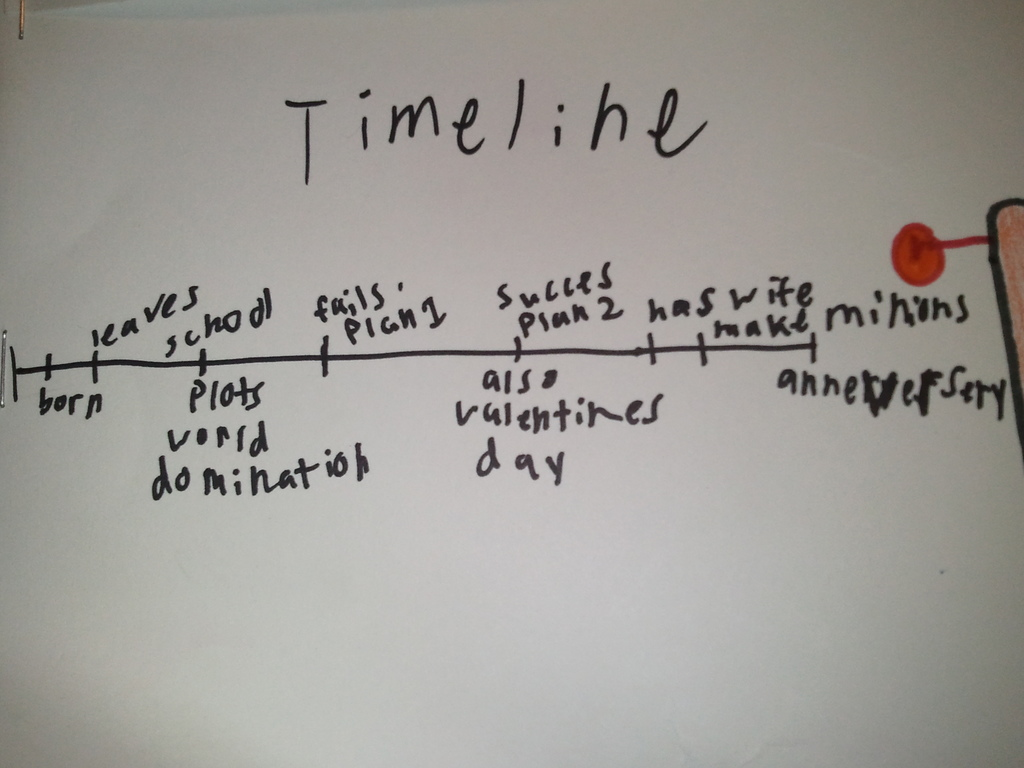What is this photo about'? The image presents a hand-drawn timeline, titled "Timeline", marked with a red pushpin on the right side. The timeline traces a series of events, beginning with "born" and concluding with "anniversary". The events are represented by small vertical lines along a black line, symbolizing the progression of time. 

The sequence of events unfolds as follows: After birth, the individual leaves school, then plots world domination. Despite an initial failure, they succeed on their second plan, savoring a taste of victory. Interestingly, this victorious moment coincides with Valentine's Day. The timeline ends with an unspecified anniversary, leaving room for interpretation and future events. 

This timeline, while simple in its visual presentation, narrates a story of ambition, resilience, victory, and celebration. It's a testament to the individual's journey, capturing key milestones and turning points in their life. 